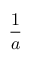Convert formula to latex. <formula><loc_0><loc_0><loc_500><loc_500>\frac { 1 } { a }</formula> 